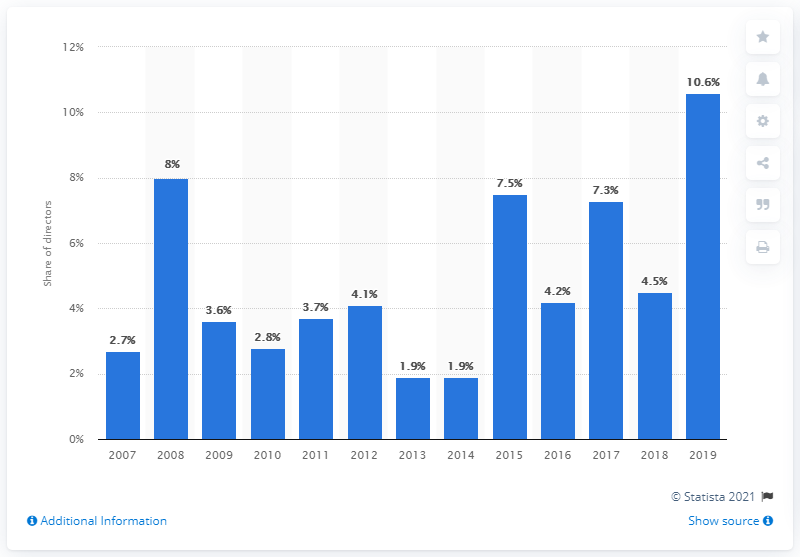Mention a couple of crucial points in this snapshot. The percentage of female directors in Hollywood was last reported in 2007. 